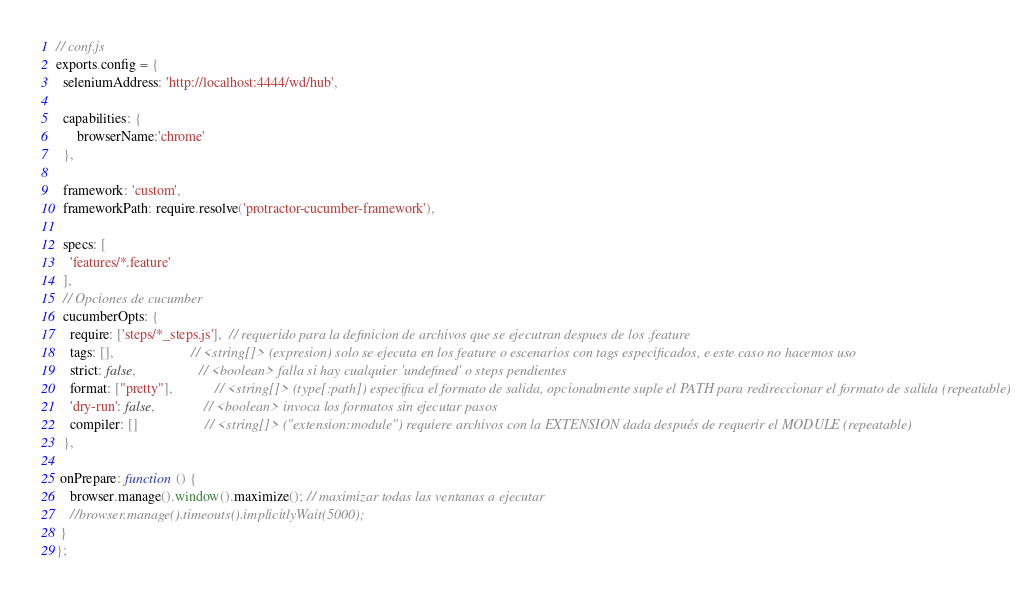<code> <loc_0><loc_0><loc_500><loc_500><_JavaScript_>// conf.js
exports.config = {
  seleniumAddress: 'http://localhost:4444/wd/hub',
  
  capabilities: {
      browserName:'chrome'
  },

  framework: 'custom',
  frameworkPath: require.resolve('protractor-cucumber-framework'),
  
  specs: [
    'features/*.feature'
  ],
  // Opciones de cucumber
  cucumberOpts: {
    require: ['steps/*_steps.js'],  // requerido para la definicion de archivos que se ejecutran despues de los .feature
    tags: [],                      // <string[]> (expresion) solo se ejecuta en los feature o escenarios con tags especificados, e este caso no hacemos uso
    strict: false,                  // <boolean> falla si hay cualquier 'undefined' o steps pendientes
    format: ["pretty"],            // <string[]> (type[:path]) especifica el formato de salida, opcionalmente suple el PATH para redireccionar el formato de salida (repeatable)
    'dry-run': false,              // <boolean> invoca los formatos sin ejecutar pasos
    compiler: []                   // <string[]> ("extension:module") requiere archivos con la EXTENSION dada después de requerir el MODULE (repeatable)
  },

 onPrepare: function () {
    browser.manage().window().maximize(); // maximizar todas las ventanas a ejecutar
    //browser.manage().timeouts().implicitlyWait(5000);
 }
};
</code> 